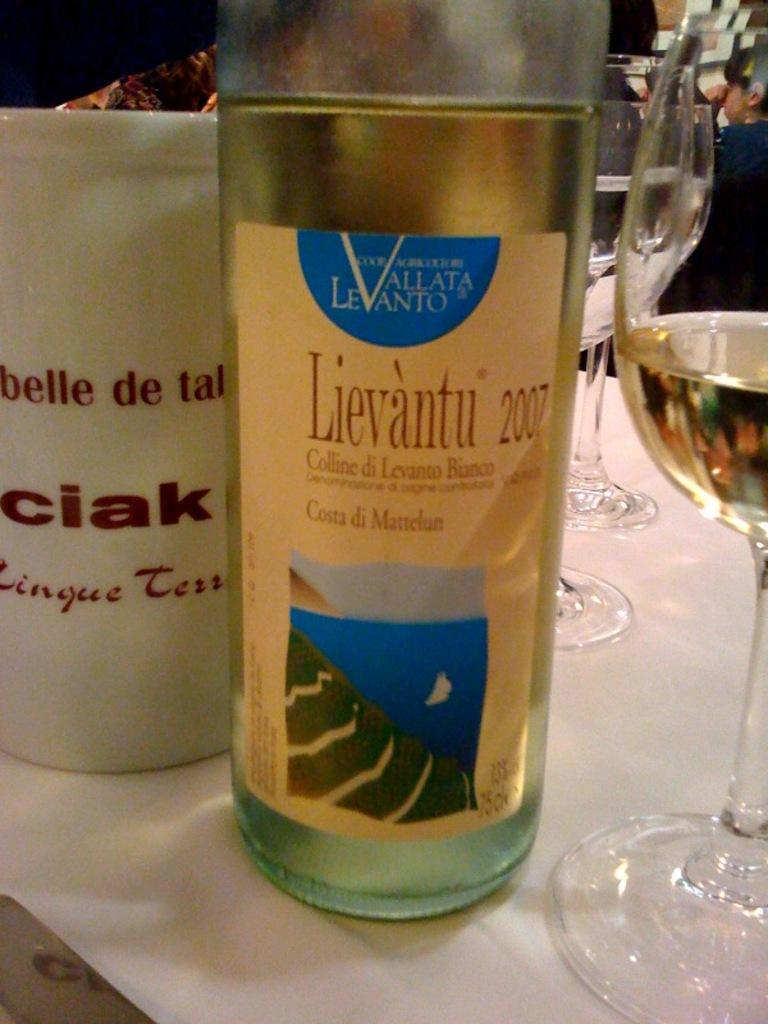Provide a one-sentence caption for the provided image. A bottle of wine is on a table and it says Lievantu 2007. 